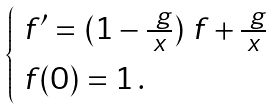Convert formula to latex. <formula><loc_0><loc_0><loc_500><loc_500>\begin{cases} \ f ^ { \prime } = ( 1 - \frac { \ g } { x } ) \ f + \frac { \ g } { x } \\ \ f ( 0 ) = 1 \, . \end{cases}</formula> 